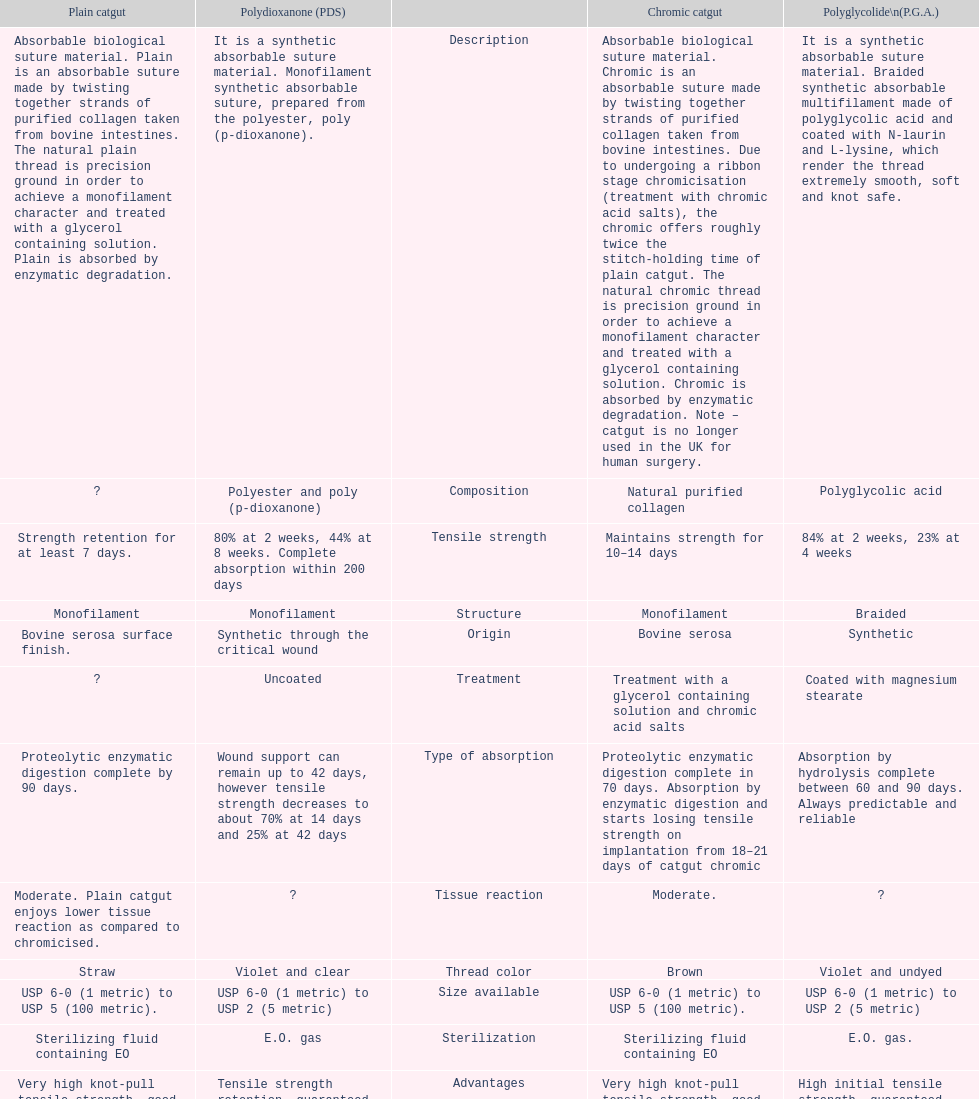Simple catgut and chromic catgut both possess what kind of architecture? Monofilament. 